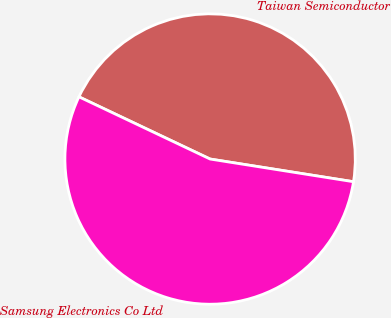Convert chart to OTSL. <chart><loc_0><loc_0><loc_500><loc_500><pie_chart><fcel>Taiwan Semiconductor<fcel>Samsung Electronics Co Ltd<nl><fcel>45.45%<fcel>54.55%<nl></chart> 